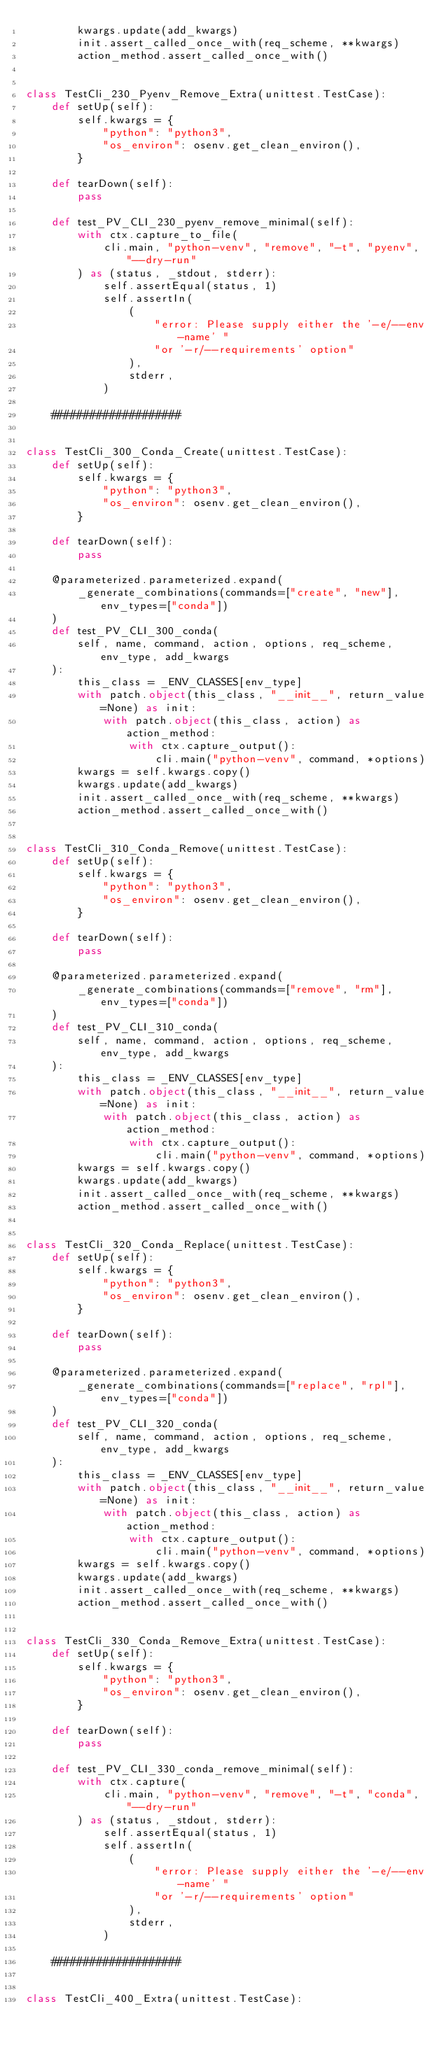<code> <loc_0><loc_0><loc_500><loc_500><_Python_>        kwargs.update(add_kwargs)
        init.assert_called_once_with(req_scheme, **kwargs)
        action_method.assert_called_once_with()


class TestCli_230_Pyenv_Remove_Extra(unittest.TestCase):
    def setUp(self):
        self.kwargs = {
            "python": "python3",
            "os_environ": osenv.get_clean_environ(),
        }

    def tearDown(self):
        pass

    def test_PV_CLI_230_pyenv_remove_minimal(self):
        with ctx.capture_to_file(
            cli.main, "python-venv", "remove", "-t", "pyenv", "--dry-run"
        ) as (status, _stdout, stderr):
            self.assertEqual(status, 1)
            self.assertIn(
                (
                    "error: Please supply either the '-e/--env-name' "
                    "or '-r/--requirements' option"
                ),
                stderr,
            )

    ####################


class TestCli_300_Conda_Create(unittest.TestCase):
    def setUp(self):
        self.kwargs = {
            "python": "python3",
            "os_environ": osenv.get_clean_environ(),
        }

    def tearDown(self):
        pass

    @parameterized.parameterized.expand(
        _generate_combinations(commands=["create", "new"], env_types=["conda"])
    )
    def test_PV_CLI_300_conda(
        self, name, command, action, options, req_scheme, env_type, add_kwargs
    ):
        this_class = _ENV_CLASSES[env_type]
        with patch.object(this_class, "__init__", return_value=None) as init:
            with patch.object(this_class, action) as action_method:
                with ctx.capture_output():
                    cli.main("python-venv", command, *options)
        kwargs = self.kwargs.copy()
        kwargs.update(add_kwargs)
        init.assert_called_once_with(req_scheme, **kwargs)
        action_method.assert_called_once_with()


class TestCli_310_Conda_Remove(unittest.TestCase):
    def setUp(self):
        self.kwargs = {
            "python": "python3",
            "os_environ": osenv.get_clean_environ(),
        }

    def tearDown(self):
        pass

    @parameterized.parameterized.expand(
        _generate_combinations(commands=["remove", "rm"], env_types=["conda"])
    )
    def test_PV_CLI_310_conda(
        self, name, command, action, options, req_scheme, env_type, add_kwargs
    ):
        this_class = _ENV_CLASSES[env_type]
        with patch.object(this_class, "__init__", return_value=None) as init:
            with patch.object(this_class, action) as action_method:
                with ctx.capture_output():
                    cli.main("python-venv", command, *options)
        kwargs = self.kwargs.copy()
        kwargs.update(add_kwargs)
        init.assert_called_once_with(req_scheme, **kwargs)
        action_method.assert_called_once_with()


class TestCli_320_Conda_Replace(unittest.TestCase):
    def setUp(self):
        self.kwargs = {
            "python": "python3",
            "os_environ": osenv.get_clean_environ(),
        }

    def tearDown(self):
        pass

    @parameterized.parameterized.expand(
        _generate_combinations(commands=["replace", "rpl"], env_types=["conda"])
    )
    def test_PV_CLI_320_conda(
        self, name, command, action, options, req_scheme, env_type, add_kwargs
    ):
        this_class = _ENV_CLASSES[env_type]
        with patch.object(this_class, "__init__", return_value=None) as init:
            with patch.object(this_class, action) as action_method:
                with ctx.capture_output():
                    cli.main("python-venv", command, *options)
        kwargs = self.kwargs.copy()
        kwargs.update(add_kwargs)
        init.assert_called_once_with(req_scheme, **kwargs)
        action_method.assert_called_once_with()


class TestCli_330_Conda_Remove_Extra(unittest.TestCase):
    def setUp(self):
        self.kwargs = {
            "python": "python3",
            "os_environ": osenv.get_clean_environ(),
        }

    def tearDown(self):
        pass

    def test_PV_CLI_330_conda_remove_minimal(self):
        with ctx.capture(
            cli.main, "python-venv", "remove", "-t", "conda", "--dry-run"
        ) as (status, _stdout, stderr):
            self.assertEqual(status, 1)
            self.assertIn(
                (
                    "error: Please supply either the '-e/--env-name' "
                    "or '-r/--requirements' option"
                ),
                stderr,
            )

    ####################


class TestCli_400_Extra(unittest.TestCase):</code> 